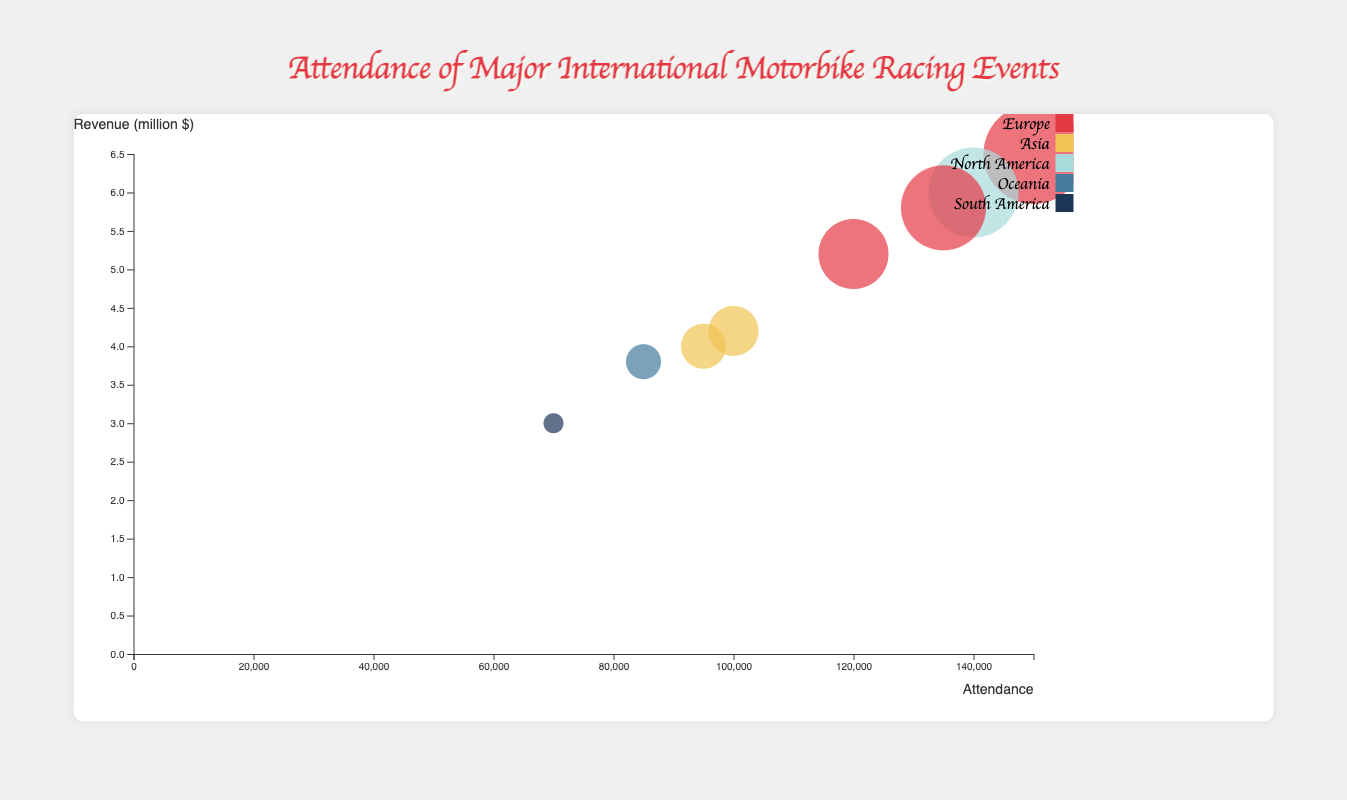How does the attendance of the Japanese Grand Prix compare to the Australian Motorcycle Grand Prix? To compare, locate both events on the chart. The Japanese Grand Prix has an attendance of 95,000, while the Australian Motorcycle Grand Prix has 85,000. 95,000 is greater than 85,000.
Answer: The Japanese Grand Prix has higher attendance Which event generated the most revenue? Identify the bubble with the highest Y-axis value. The MotoGP Grand Prix of Italy has the highest revenue at 6.5 million dollars.
Answer: MotoGP Grand Prix of Italy What is the total attendance for North American and South American events combined? Sum the attendance of the MotoGP of the Americas (140,000) and the Argentine Grand Prix (70,000). Total attendance is 140,000 + 70,000 = 210,000.
Answer: 210,000 What region has the highest cumulative attendance? Sum the attendance for each region and compare. Europe: 150,000 + 120,000 + 135,000 = 405,000; Asia: 95,000 + 100,000 = 195,000; North America: 140,000; Oceania: 85,000; South America: 70,000. Europe has the highest cumulative attendance.
Answer: Europe Which event in Europe has the lowest revenue? Compare the Y-axis values of the European events. The Red Bull Ring MotoGP has the lowest revenue in Europe at 5.2 million dollars.
Answer: Red Bull Ring MotoGP What are the average attendance and revenue for events in Asia? Calculate the average attendance (95,000 + 100,000)/2 = 97,500 and average revenue (4.0 + 4.2)/2 = 4.1 million dollars for Asian events.
Answer: 97,500 and 4.1 million dollars Which event has the largest bubble and what does it represent? The size of the bubble corresponds to attendance. The MotoGP Grand Prix of Italy has the largest bubble, representing an attendance of 150,000.
Answer: MotoGP Grand Prix of Italy What is the difference in revenue between the British Grand Prix MotoGP and the Malaysian Motorcycle Grand Prix? Subtract the revenue of the Malaysian Motorcycle Grand Prix (4.2 million dollars) from the British Grand Prix MotoGP (5.8 million dollars). The difference is 5.8 - 4.2 = 1.6 million dollars.
Answer: 1.6 million dollars Which events have an attendance within 10,000 of each other? Compare the attendance values and find events with close attendance. The British Grand Prix MotoGP (135,000) and the MotoGP of the Americas (140,000) differ by 5,000.
Answer: British Grand Prix MotoGP and MotoGP of the Americas 